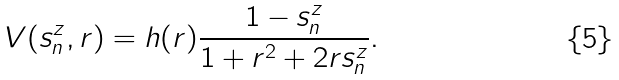<formula> <loc_0><loc_0><loc_500><loc_500>V ( s _ { n } ^ { z } , r ) = h ( r ) \frac { 1 - s _ { n } ^ { z } } { 1 + r ^ { 2 } + 2 r s _ { n } ^ { z } } .</formula> 